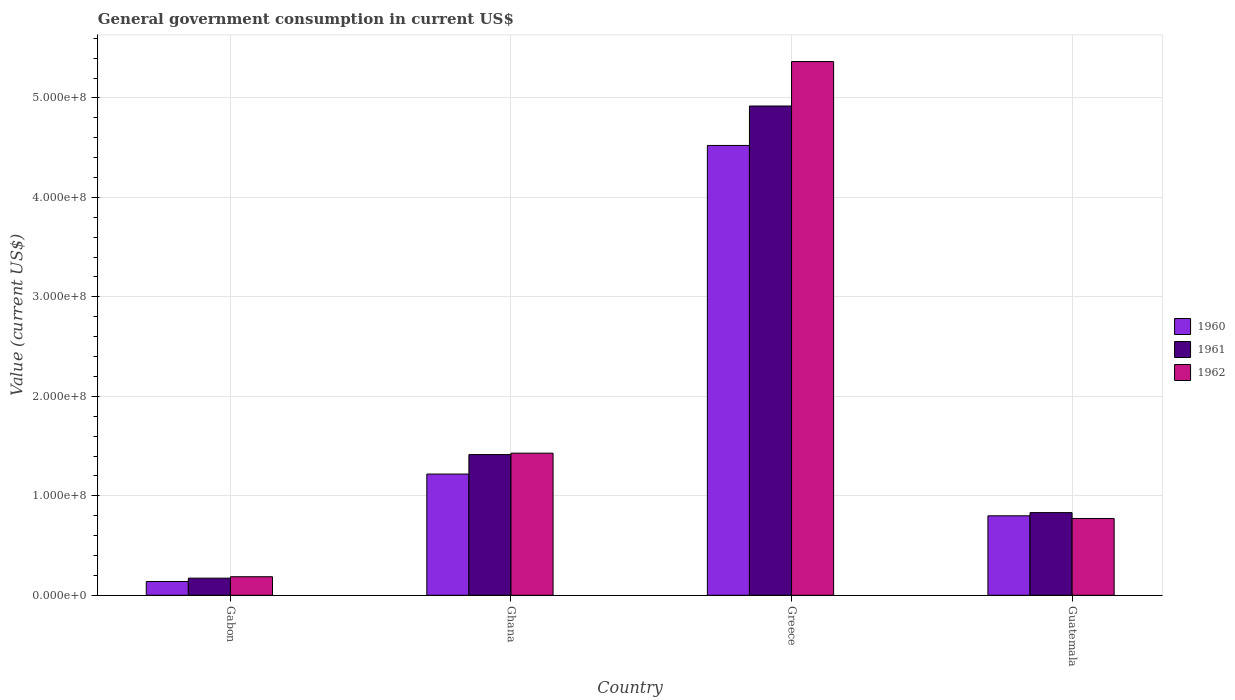How many different coloured bars are there?
Your response must be concise. 3. Are the number of bars per tick equal to the number of legend labels?
Provide a short and direct response. Yes. Are the number of bars on each tick of the X-axis equal?
Make the answer very short. Yes. How many bars are there on the 4th tick from the right?
Provide a succinct answer. 3. In how many cases, is the number of bars for a given country not equal to the number of legend labels?
Ensure brevity in your answer.  0. What is the government conusmption in 1960 in Guatemala?
Offer a very short reply. 7.99e+07. Across all countries, what is the maximum government conusmption in 1960?
Your answer should be very brief. 4.52e+08. Across all countries, what is the minimum government conusmption in 1962?
Give a very brief answer. 1.86e+07. In which country was the government conusmption in 1961 maximum?
Your response must be concise. Greece. In which country was the government conusmption in 1962 minimum?
Your answer should be compact. Gabon. What is the total government conusmption in 1961 in the graph?
Ensure brevity in your answer.  7.34e+08. What is the difference between the government conusmption in 1961 in Gabon and that in Ghana?
Keep it short and to the point. -1.24e+08. What is the difference between the government conusmption in 1961 in Gabon and the government conusmption in 1960 in Ghana?
Your answer should be compact. -1.05e+08. What is the average government conusmption in 1960 per country?
Ensure brevity in your answer.  1.67e+08. What is the difference between the government conusmption of/in 1961 and government conusmption of/in 1962 in Greece?
Make the answer very short. -4.47e+07. In how many countries, is the government conusmption in 1962 greater than 220000000 US$?
Provide a short and direct response. 1. What is the ratio of the government conusmption in 1962 in Gabon to that in Greece?
Your answer should be compact. 0.03. Is the government conusmption in 1960 in Gabon less than that in Guatemala?
Your response must be concise. Yes. What is the difference between the highest and the second highest government conusmption in 1962?
Provide a succinct answer. -6.57e+07. What is the difference between the highest and the lowest government conusmption in 1961?
Keep it short and to the point. 4.75e+08. What does the 1st bar from the left in Guatemala represents?
Offer a terse response. 1960. How many countries are there in the graph?
Offer a very short reply. 4. Are the values on the major ticks of Y-axis written in scientific E-notation?
Keep it short and to the point. Yes. Where does the legend appear in the graph?
Provide a short and direct response. Center right. How many legend labels are there?
Offer a terse response. 3. How are the legend labels stacked?
Make the answer very short. Vertical. What is the title of the graph?
Your answer should be compact. General government consumption in current US$. What is the label or title of the X-axis?
Offer a very short reply. Country. What is the label or title of the Y-axis?
Offer a terse response. Value (current US$). What is the Value (current US$) of 1960 in Gabon?
Offer a very short reply. 1.38e+07. What is the Value (current US$) in 1961 in Gabon?
Your answer should be very brief. 1.72e+07. What is the Value (current US$) of 1962 in Gabon?
Provide a succinct answer. 1.86e+07. What is the Value (current US$) in 1960 in Ghana?
Keep it short and to the point. 1.22e+08. What is the Value (current US$) of 1961 in Ghana?
Your answer should be compact. 1.41e+08. What is the Value (current US$) of 1962 in Ghana?
Your answer should be very brief. 1.43e+08. What is the Value (current US$) in 1960 in Greece?
Ensure brevity in your answer.  4.52e+08. What is the Value (current US$) in 1961 in Greece?
Keep it short and to the point. 4.92e+08. What is the Value (current US$) in 1962 in Greece?
Offer a terse response. 5.37e+08. What is the Value (current US$) of 1960 in Guatemala?
Make the answer very short. 7.99e+07. What is the Value (current US$) of 1961 in Guatemala?
Keep it short and to the point. 8.31e+07. What is the Value (current US$) in 1962 in Guatemala?
Your answer should be very brief. 7.72e+07. Across all countries, what is the maximum Value (current US$) of 1960?
Offer a very short reply. 4.52e+08. Across all countries, what is the maximum Value (current US$) in 1961?
Make the answer very short. 4.92e+08. Across all countries, what is the maximum Value (current US$) in 1962?
Your answer should be compact. 5.37e+08. Across all countries, what is the minimum Value (current US$) in 1960?
Provide a short and direct response. 1.38e+07. Across all countries, what is the minimum Value (current US$) in 1961?
Make the answer very short. 1.72e+07. Across all countries, what is the minimum Value (current US$) of 1962?
Ensure brevity in your answer.  1.86e+07. What is the total Value (current US$) in 1960 in the graph?
Keep it short and to the point. 6.68e+08. What is the total Value (current US$) of 1961 in the graph?
Keep it short and to the point. 7.34e+08. What is the total Value (current US$) of 1962 in the graph?
Give a very brief answer. 7.75e+08. What is the difference between the Value (current US$) of 1960 in Gabon and that in Ghana?
Your answer should be very brief. -1.08e+08. What is the difference between the Value (current US$) in 1961 in Gabon and that in Ghana?
Provide a short and direct response. -1.24e+08. What is the difference between the Value (current US$) of 1962 in Gabon and that in Ghana?
Provide a short and direct response. -1.24e+08. What is the difference between the Value (current US$) of 1960 in Gabon and that in Greece?
Offer a very short reply. -4.38e+08. What is the difference between the Value (current US$) of 1961 in Gabon and that in Greece?
Your answer should be very brief. -4.75e+08. What is the difference between the Value (current US$) in 1962 in Gabon and that in Greece?
Offer a very short reply. -5.18e+08. What is the difference between the Value (current US$) of 1960 in Gabon and that in Guatemala?
Give a very brief answer. -6.61e+07. What is the difference between the Value (current US$) in 1961 in Gabon and that in Guatemala?
Provide a short and direct response. -6.59e+07. What is the difference between the Value (current US$) of 1962 in Gabon and that in Guatemala?
Provide a short and direct response. -5.86e+07. What is the difference between the Value (current US$) in 1960 in Ghana and that in Greece?
Offer a terse response. -3.30e+08. What is the difference between the Value (current US$) of 1961 in Ghana and that in Greece?
Keep it short and to the point. -3.50e+08. What is the difference between the Value (current US$) in 1962 in Ghana and that in Greece?
Provide a succinct answer. -3.94e+08. What is the difference between the Value (current US$) in 1960 in Ghana and that in Guatemala?
Keep it short and to the point. 4.20e+07. What is the difference between the Value (current US$) in 1961 in Ghana and that in Guatemala?
Your answer should be very brief. 5.84e+07. What is the difference between the Value (current US$) in 1962 in Ghana and that in Guatemala?
Provide a short and direct response. 6.57e+07. What is the difference between the Value (current US$) in 1960 in Greece and that in Guatemala?
Offer a very short reply. 3.72e+08. What is the difference between the Value (current US$) in 1961 in Greece and that in Guatemala?
Ensure brevity in your answer.  4.09e+08. What is the difference between the Value (current US$) of 1962 in Greece and that in Guatemala?
Keep it short and to the point. 4.59e+08. What is the difference between the Value (current US$) in 1960 in Gabon and the Value (current US$) in 1961 in Ghana?
Give a very brief answer. -1.28e+08. What is the difference between the Value (current US$) in 1960 in Gabon and the Value (current US$) in 1962 in Ghana?
Your answer should be compact. -1.29e+08. What is the difference between the Value (current US$) in 1961 in Gabon and the Value (current US$) in 1962 in Ghana?
Offer a terse response. -1.26e+08. What is the difference between the Value (current US$) of 1960 in Gabon and the Value (current US$) of 1961 in Greece?
Your response must be concise. -4.78e+08. What is the difference between the Value (current US$) in 1960 in Gabon and the Value (current US$) in 1962 in Greece?
Offer a terse response. -5.23e+08. What is the difference between the Value (current US$) of 1961 in Gabon and the Value (current US$) of 1962 in Greece?
Provide a succinct answer. -5.19e+08. What is the difference between the Value (current US$) in 1960 in Gabon and the Value (current US$) in 1961 in Guatemala?
Make the answer very short. -6.93e+07. What is the difference between the Value (current US$) in 1960 in Gabon and the Value (current US$) in 1962 in Guatemala?
Provide a succinct answer. -6.34e+07. What is the difference between the Value (current US$) of 1961 in Gabon and the Value (current US$) of 1962 in Guatemala?
Provide a short and direct response. -6.00e+07. What is the difference between the Value (current US$) in 1960 in Ghana and the Value (current US$) in 1961 in Greece?
Keep it short and to the point. -3.70e+08. What is the difference between the Value (current US$) of 1960 in Ghana and the Value (current US$) of 1962 in Greece?
Offer a terse response. -4.15e+08. What is the difference between the Value (current US$) of 1961 in Ghana and the Value (current US$) of 1962 in Greece?
Provide a short and direct response. -3.95e+08. What is the difference between the Value (current US$) of 1960 in Ghana and the Value (current US$) of 1961 in Guatemala?
Provide a succinct answer. 3.88e+07. What is the difference between the Value (current US$) of 1960 in Ghana and the Value (current US$) of 1962 in Guatemala?
Give a very brief answer. 4.47e+07. What is the difference between the Value (current US$) in 1961 in Ghana and the Value (current US$) in 1962 in Guatemala?
Keep it short and to the point. 6.43e+07. What is the difference between the Value (current US$) in 1960 in Greece and the Value (current US$) in 1961 in Guatemala?
Keep it short and to the point. 3.69e+08. What is the difference between the Value (current US$) in 1960 in Greece and the Value (current US$) in 1962 in Guatemala?
Your answer should be compact. 3.75e+08. What is the difference between the Value (current US$) of 1961 in Greece and the Value (current US$) of 1962 in Guatemala?
Keep it short and to the point. 4.15e+08. What is the average Value (current US$) of 1960 per country?
Your response must be concise. 1.67e+08. What is the average Value (current US$) in 1961 per country?
Make the answer very short. 1.83e+08. What is the average Value (current US$) of 1962 per country?
Your answer should be compact. 1.94e+08. What is the difference between the Value (current US$) in 1960 and Value (current US$) in 1961 in Gabon?
Ensure brevity in your answer.  -3.38e+06. What is the difference between the Value (current US$) in 1960 and Value (current US$) in 1962 in Gabon?
Give a very brief answer. -4.81e+06. What is the difference between the Value (current US$) in 1961 and Value (current US$) in 1962 in Gabon?
Give a very brief answer. -1.43e+06. What is the difference between the Value (current US$) of 1960 and Value (current US$) of 1961 in Ghana?
Your response must be concise. -1.96e+07. What is the difference between the Value (current US$) of 1960 and Value (current US$) of 1962 in Ghana?
Give a very brief answer. -2.10e+07. What is the difference between the Value (current US$) of 1961 and Value (current US$) of 1962 in Ghana?
Your answer should be compact. -1.40e+06. What is the difference between the Value (current US$) in 1960 and Value (current US$) in 1961 in Greece?
Give a very brief answer. -3.96e+07. What is the difference between the Value (current US$) in 1960 and Value (current US$) in 1962 in Greece?
Your answer should be compact. -8.43e+07. What is the difference between the Value (current US$) in 1961 and Value (current US$) in 1962 in Greece?
Your response must be concise. -4.47e+07. What is the difference between the Value (current US$) in 1960 and Value (current US$) in 1961 in Guatemala?
Your answer should be compact. -3.20e+06. What is the difference between the Value (current US$) of 1960 and Value (current US$) of 1962 in Guatemala?
Offer a very short reply. 2.70e+06. What is the difference between the Value (current US$) of 1961 and Value (current US$) of 1962 in Guatemala?
Ensure brevity in your answer.  5.90e+06. What is the ratio of the Value (current US$) of 1960 in Gabon to that in Ghana?
Offer a very short reply. 0.11. What is the ratio of the Value (current US$) in 1961 in Gabon to that in Ghana?
Provide a succinct answer. 0.12. What is the ratio of the Value (current US$) of 1962 in Gabon to that in Ghana?
Keep it short and to the point. 0.13. What is the ratio of the Value (current US$) in 1960 in Gabon to that in Greece?
Provide a succinct answer. 0.03. What is the ratio of the Value (current US$) in 1961 in Gabon to that in Greece?
Ensure brevity in your answer.  0.04. What is the ratio of the Value (current US$) in 1962 in Gabon to that in Greece?
Give a very brief answer. 0.03. What is the ratio of the Value (current US$) in 1960 in Gabon to that in Guatemala?
Your response must be concise. 0.17. What is the ratio of the Value (current US$) of 1961 in Gabon to that in Guatemala?
Your answer should be very brief. 0.21. What is the ratio of the Value (current US$) of 1962 in Gabon to that in Guatemala?
Offer a terse response. 0.24. What is the ratio of the Value (current US$) of 1960 in Ghana to that in Greece?
Ensure brevity in your answer.  0.27. What is the ratio of the Value (current US$) of 1961 in Ghana to that in Greece?
Give a very brief answer. 0.29. What is the ratio of the Value (current US$) in 1962 in Ghana to that in Greece?
Give a very brief answer. 0.27. What is the ratio of the Value (current US$) in 1960 in Ghana to that in Guatemala?
Give a very brief answer. 1.53. What is the ratio of the Value (current US$) in 1961 in Ghana to that in Guatemala?
Your answer should be compact. 1.7. What is the ratio of the Value (current US$) in 1962 in Ghana to that in Guatemala?
Provide a succinct answer. 1.85. What is the ratio of the Value (current US$) of 1960 in Greece to that in Guatemala?
Provide a short and direct response. 5.66. What is the ratio of the Value (current US$) in 1961 in Greece to that in Guatemala?
Provide a short and direct response. 5.92. What is the ratio of the Value (current US$) in 1962 in Greece to that in Guatemala?
Give a very brief answer. 6.95. What is the difference between the highest and the second highest Value (current US$) in 1960?
Your response must be concise. 3.30e+08. What is the difference between the highest and the second highest Value (current US$) in 1961?
Provide a succinct answer. 3.50e+08. What is the difference between the highest and the second highest Value (current US$) in 1962?
Offer a very short reply. 3.94e+08. What is the difference between the highest and the lowest Value (current US$) in 1960?
Your response must be concise. 4.38e+08. What is the difference between the highest and the lowest Value (current US$) of 1961?
Your answer should be very brief. 4.75e+08. What is the difference between the highest and the lowest Value (current US$) of 1962?
Ensure brevity in your answer.  5.18e+08. 